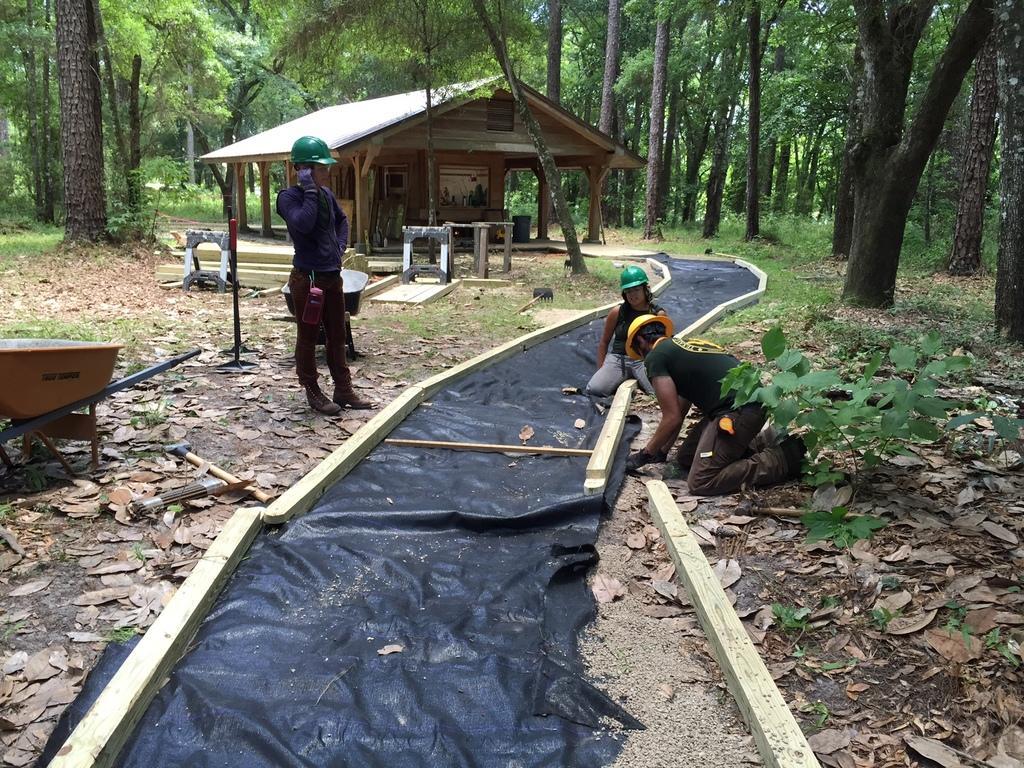Can you describe this image briefly? In the middle of the image few people are standing and sitting. Behind them there is a shed and there are some trees. Bottom of the image there are some leaves. Bottom left side of the image there is a cart. Bottom right side of the there are some plants. 